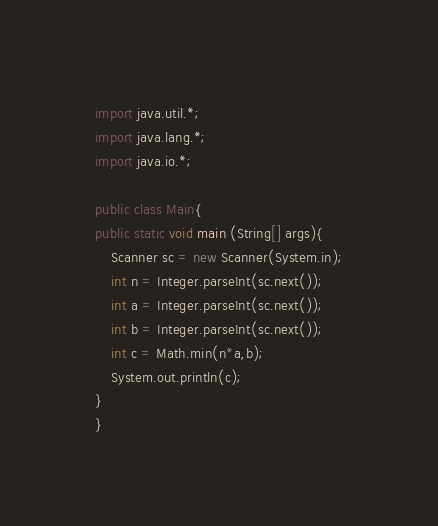<code> <loc_0><loc_0><loc_500><loc_500><_Java_>import java.util.*;
import java.lang.*;
import java.io.*;

public class Main{
public static void main (String[] args){
	Scanner sc = new Scanner(System.in);
	int n = Integer.parseInt(sc.next());
	int a = Integer.parseInt(sc.next());
	int b = Integer.parseInt(sc.next());
	int c = Math.min(n*a,b);
	System.out.println(c);
}
}
</code> 